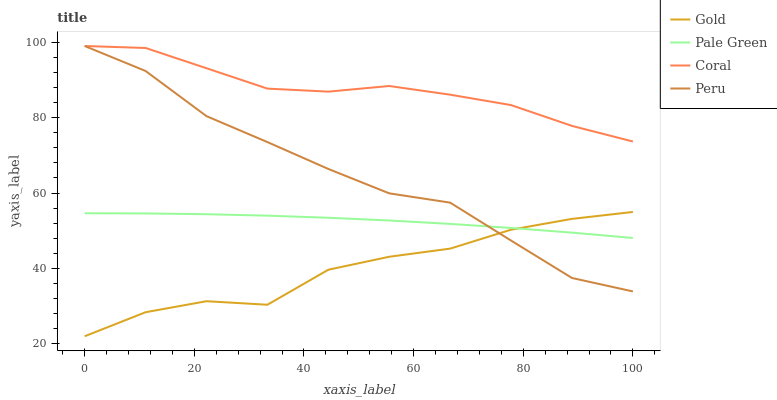Does Gold have the minimum area under the curve?
Answer yes or no. Yes. Does Coral have the maximum area under the curve?
Answer yes or no. Yes. Does Pale Green have the minimum area under the curve?
Answer yes or no. No. Does Pale Green have the maximum area under the curve?
Answer yes or no. No. Is Pale Green the smoothest?
Answer yes or no. Yes. Is Gold the roughest?
Answer yes or no. Yes. Is Peru the smoothest?
Answer yes or no. No. Is Peru the roughest?
Answer yes or no. No. Does Gold have the lowest value?
Answer yes or no. Yes. Does Pale Green have the lowest value?
Answer yes or no. No. Does Peru have the highest value?
Answer yes or no. Yes. Does Pale Green have the highest value?
Answer yes or no. No. Is Gold less than Coral?
Answer yes or no. Yes. Is Coral greater than Pale Green?
Answer yes or no. Yes. Does Gold intersect Pale Green?
Answer yes or no. Yes. Is Gold less than Pale Green?
Answer yes or no. No. Is Gold greater than Pale Green?
Answer yes or no. No. Does Gold intersect Coral?
Answer yes or no. No. 